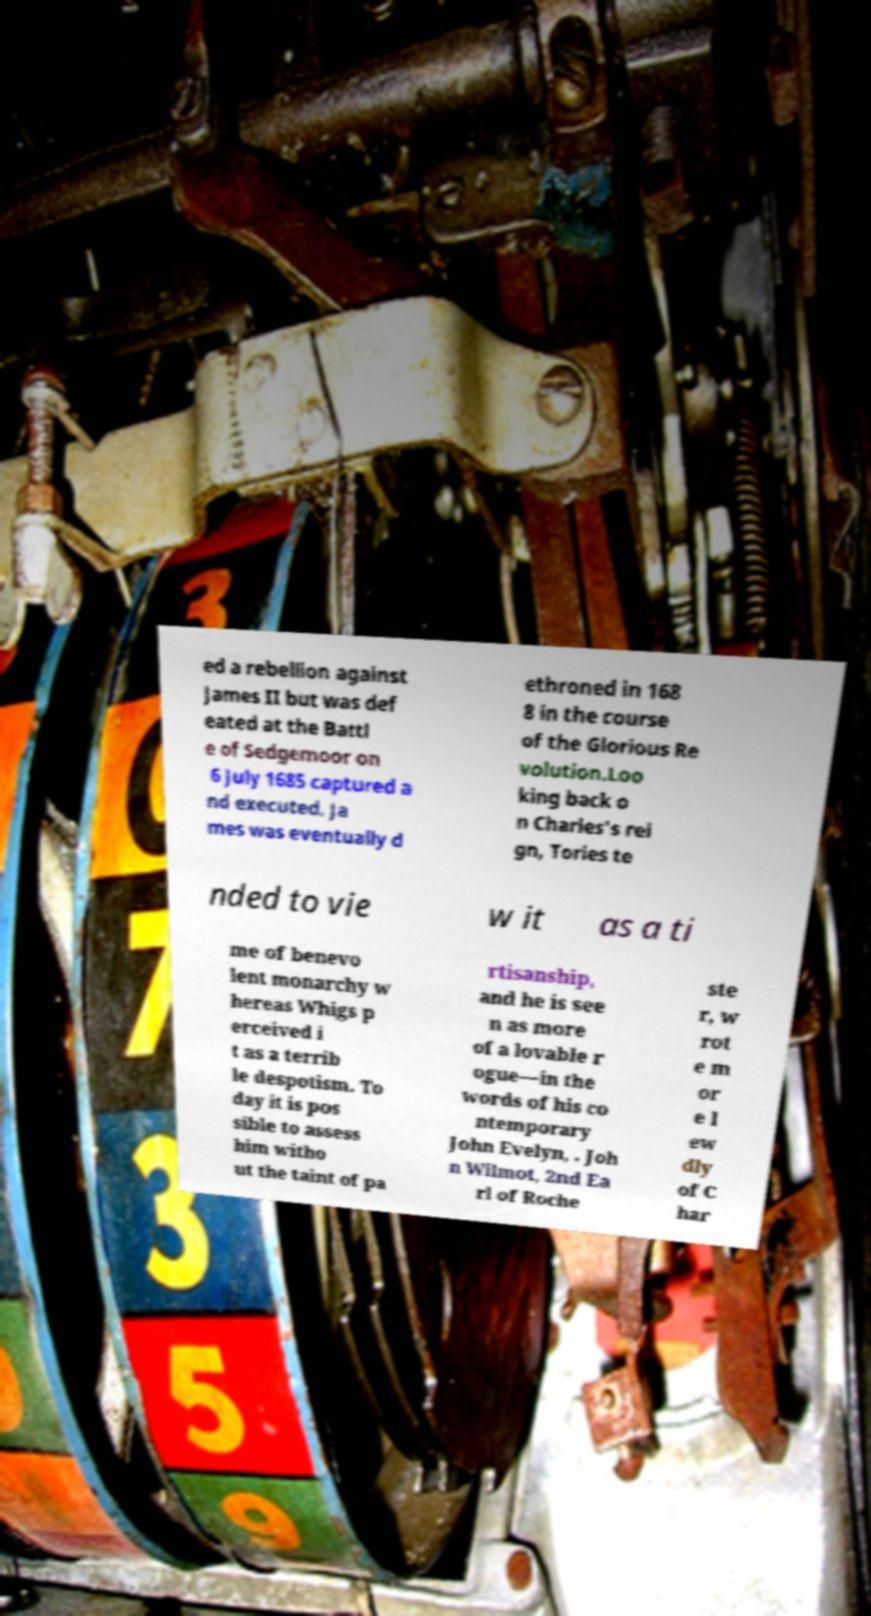Can you accurately transcribe the text from the provided image for me? ed a rebellion against James II but was def eated at the Battl e of Sedgemoor on 6 July 1685 captured a nd executed. Ja mes was eventually d ethroned in 168 8 in the course of the Glorious Re volution.Loo king back o n Charles's rei gn, Tories te nded to vie w it as a ti me of benevo lent monarchy w hereas Whigs p erceived i t as a terrib le despotism. To day it is pos sible to assess him witho ut the taint of pa rtisanship, and he is see n as more of a lovable r ogue—in the words of his co ntemporary John Evelyn, . Joh n Wilmot, 2nd Ea rl of Roche ste r, w rot e m or e l ew dly of C har 